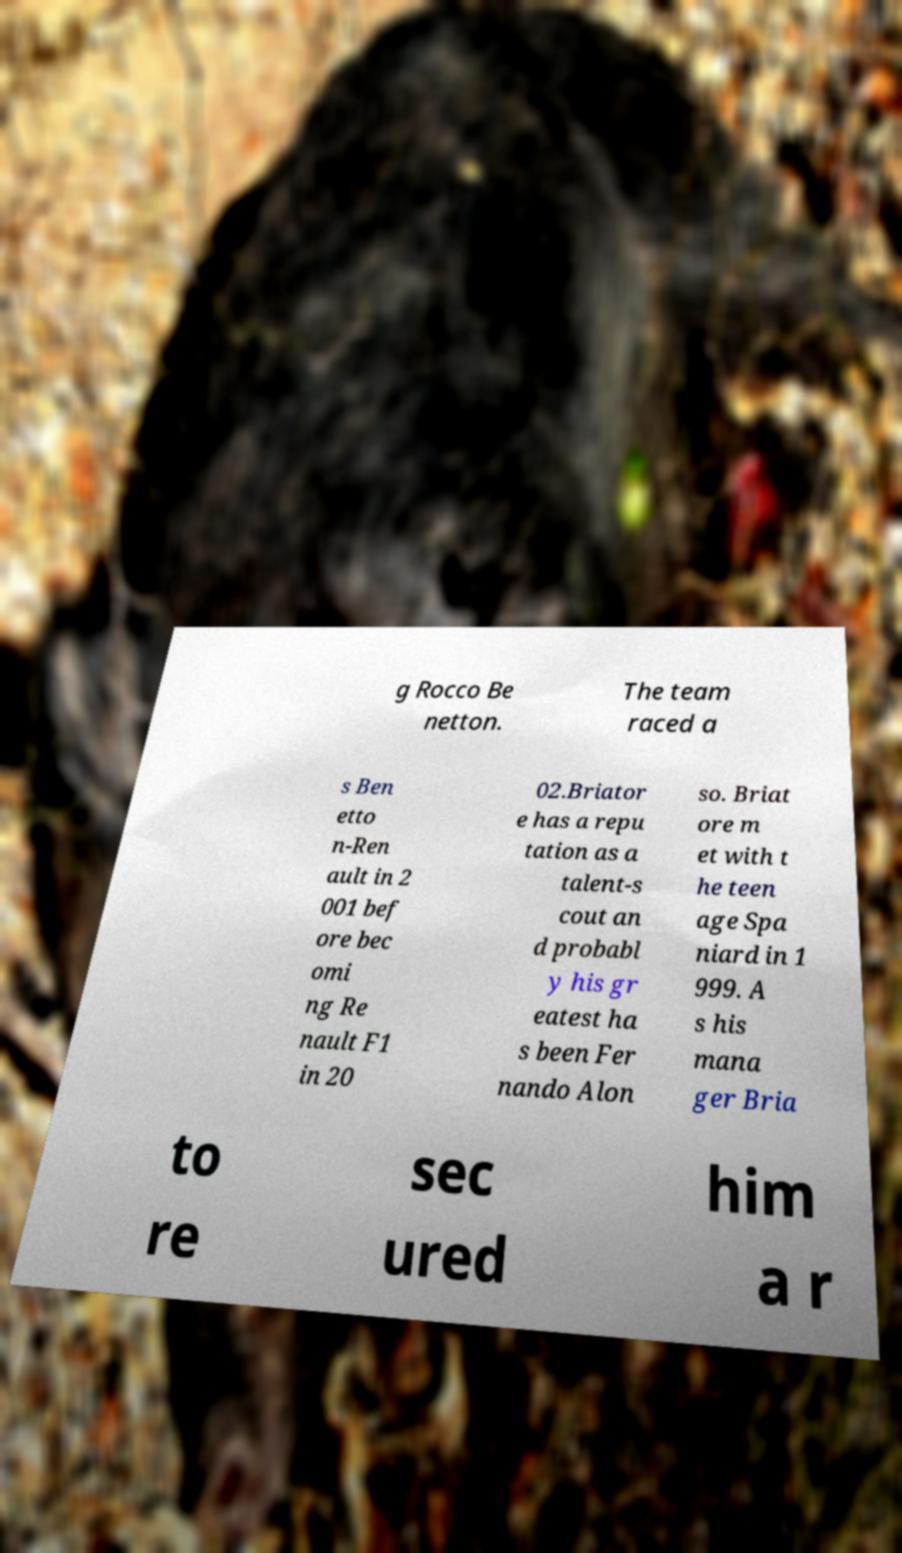I need the written content from this picture converted into text. Can you do that? g Rocco Be netton. The team raced a s Ben etto n-Ren ault in 2 001 bef ore bec omi ng Re nault F1 in 20 02.Briator e has a repu tation as a talent-s cout an d probabl y his gr eatest ha s been Fer nando Alon so. Briat ore m et with t he teen age Spa niard in 1 999. A s his mana ger Bria to re sec ured him a r 